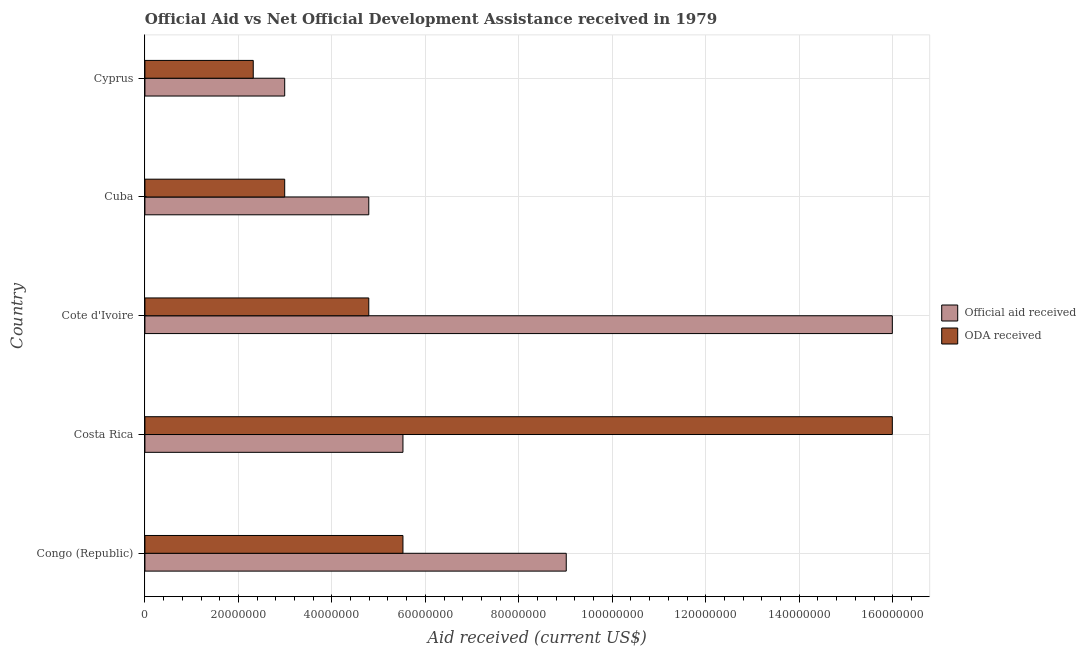How many bars are there on the 3rd tick from the top?
Make the answer very short. 2. How many bars are there on the 3rd tick from the bottom?
Your answer should be compact. 2. What is the label of the 5th group of bars from the top?
Offer a terse response. Congo (Republic). In how many cases, is the number of bars for a given country not equal to the number of legend labels?
Provide a succinct answer. 0. What is the oda received in Costa Rica?
Ensure brevity in your answer.  1.60e+08. Across all countries, what is the maximum oda received?
Your response must be concise. 1.60e+08. Across all countries, what is the minimum oda received?
Your response must be concise. 2.32e+07. In which country was the official aid received maximum?
Your response must be concise. Cote d'Ivoire. In which country was the official aid received minimum?
Your answer should be compact. Cyprus. What is the total official aid received in the graph?
Provide a succinct answer. 3.83e+08. What is the difference between the official aid received in Cuba and that in Cyprus?
Provide a short and direct response. 1.80e+07. What is the difference between the oda received in Cyprus and the official aid received in Congo (Republic)?
Give a very brief answer. -6.70e+07. What is the average oda received per country?
Keep it short and to the point. 6.32e+07. What is the difference between the official aid received and oda received in Congo (Republic)?
Your response must be concise. 3.49e+07. What is the ratio of the oda received in Congo (Republic) to that in Costa Rica?
Provide a succinct answer. 0.34. What is the difference between the highest and the second highest oda received?
Ensure brevity in your answer.  1.05e+08. What is the difference between the highest and the lowest oda received?
Offer a very short reply. 1.37e+08. Is the sum of the oda received in Congo (Republic) and Cyprus greater than the maximum official aid received across all countries?
Give a very brief answer. No. What does the 2nd bar from the top in Costa Rica represents?
Make the answer very short. Official aid received. What does the 1st bar from the bottom in Congo (Republic) represents?
Your answer should be very brief. Official aid received. How many bars are there?
Your answer should be very brief. 10. Are all the bars in the graph horizontal?
Give a very brief answer. Yes. How many countries are there in the graph?
Your answer should be compact. 5. Does the graph contain any zero values?
Your response must be concise. No. Where does the legend appear in the graph?
Offer a very short reply. Center right. How are the legend labels stacked?
Ensure brevity in your answer.  Vertical. What is the title of the graph?
Provide a succinct answer. Official Aid vs Net Official Development Assistance received in 1979 . Does "Total Population" appear as one of the legend labels in the graph?
Ensure brevity in your answer.  No. What is the label or title of the X-axis?
Your answer should be very brief. Aid received (current US$). What is the label or title of the Y-axis?
Provide a short and direct response. Country. What is the Aid received (current US$) of Official aid received in Congo (Republic)?
Give a very brief answer. 9.02e+07. What is the Aid received (current US$) in ODA received in Congo (Republic)?
Offer a very short reply. 5.52e+07. What is the Aid received (current US$) of Official aid received in Costa Rica?
Provide a succinct answer. 5.52e+07. What is the Aid received (current US$) of ODA received in Costa Rica?
Offer a very short reply. 1.60e+08. What is the Aid received (current US$) of Official aid received in Cote d'Ivoire?
Provide a short and direct response. 1.60e+08. What is the Aid received (current US$) of ODA received in Cote d'Ivoire?
Your answer should be compact. 4.79e+07. What is the Aid received (current US$) of Official aid received in Cuba?
Make the answer very short. 4.79e+07. What is the Aid received (current US$) of ODA received in Cuba?
Provide a short and direct response. 2.99e+07. What is the Aid received (current US$) in Official aid received in Cyprus?
Provide a succinct answer. 2.99e+07. What is the Aid received (current US$) in ODA received in Cyprus?
Keep it short and to the point. 2.32e+07. Across all countries, what is the maximum Aid received (current US$) of Official aid received?
Your answer should be very brief. 1.60e+08. Across all countries, what is the maximum Aid received (current US$) in ODA received?
Your answer should be compact. 1.60e+08. Across all countries, what is the minimum Aid received (current US$) in Official aid received?
Your response must be concise. 2.99e+07. Across all countries, what is the minimum Aid received (current US$) of ODA received?
Your response must be concise. 2.32e+07. What is the total Aid received (current US$) in Official aid received in the graph?
Your response must be concise. 3.83e+08. What is the total Aid received (current US$) of ODA received in the graph?
Offer a terse response. 3.16e+08. What is the difference between the Aid received (current US$) of Official aid received in Congo (Republic) and that in Costa Rica?
Provide a short and direct response. 3.49e+07. What is the difference between the Aid received (current US$) of ODA received in Congo (Republic) and that in Costa Rica?
Offer a terse response. -1.05e+08. What is the difference between the Aid received (current US$) of Official aid received in Congo (Republic) and that in Cote d'Ivoire?
Offer a terse response. -6.98e+07. What is the difference between the Aid received (current US$) of ODA received in Congo (Republic) and that in Cote d'Ivoire?
Your answer should be very brief. 7.31e+06. What is the difference between the Aid received (current US$) in Official aid received in Congo (Republic) and that in Cuba?
Offer a terse response. 4.22e+07. What is the difference between the Aid received (current US$) in ODA received in Congo (Republic) and that in Cuba?
Your answer should be very brief. 2.53e+07. What is the difference between the Aid received (current US$) of Official aid received in Congo (Republic) and that in Cyprus?
Your response must be concise. 6.02e+07. What is the difference between the Aid received (current US$) of ODA received in Congo (Republic) and that in Cyprus?
Your answer should be compact. 3.20e+07. What is the difference between the Aid received (current US$) in Official aid received in Costa Rica and that in Cote d'Ivoire?
Make the answer very short. -1.05e+08. What is the difference between the Aid received (current US$) in ODA received in Costa Rica and that in Cote d'Ivoire?
Your response must be concise. 1.12e+08. What is the difference between the Aid received (current US$) in Official aid received in Costa Rica and that in Cuba?
Provide a short and direct response. 7.31e+06. What is the difference between the Aid received (current US$) of ODA received in Costa Rica and that in Cuba?
Keep it short and to the point. 1.30e+08. What is the difference between the Aid received (current US$) of Official aid received in Costa Rica and that in Cyprus?
Ensure brevity in your answer.  2.53e+07. What is the difference between the Aid received (current US$) in ODA received in Costa Rica and that in Cyprus?
Provide a succinct answer. 1.37e+08. What is the difference between the Aid received (current US$) of Official aid received in Cote d'Ivoire and that in Cuba?
Offer a terse response. 1.12e+08. What is the difference between the Aid received (current US$) of ODA received in Cote d'Ivoire and that in Cuba?
Provide a succinct answer. 1.80e+07. What is the difference between the Aid received (current US$) in Official aid received in Cote d'Ivoire and that in Cyprus?
Provide a succinct answer. 1.30e+08. What is the difference between the Aid received (current US$) of ODA received in Cote d'Ivoire and that in Cyprus?
Your answer should be compact. 2.47e+07. What is the difference between the Aid received (current US$) of Official aid received in Cuba and that in Cyprus?
Provide a succinct answer. 1.80e+07. What is the difference between the Aid received (current US$) in ODA received in Cuba and that in Cyprus?
Provide a succinct answer. 6.73e+06. What is the difference between the Aid received (current US$) of Official aid received in Congo (Republic) and the Aid received (current US$) of ODA received in Costa Rica?
Ensure brevity in your answer.  -6.98e+07. What is the difference between the Aid received (current US$) of Official aid received in Congo (Republic) and the Aid received (current US$) of ODA received in Cote d'Ivoire?
Make the answer very short. 4.22e+07. What is the difference between the Aid received (current US$) in Official aid received in Congo (Republic) and the Aid received (current US$) in ODA received in Cuba?
Keep it short and to the point. 6.02e+07. What is the difference between the Aid received (current US$) in Official aid received in Congo (Republic) and the Aid received (current US$) in ODA received in Cyprus?
Offer a terse response. 6.70e+07. What is the difference between the Aid received (current US$) in Official aid received in Costa Rica and the Aid received (current US$) in ODA received in Cote d'Ivoire?
Provide a succinct answer. 7.31e+06. What is the difference between the Aid received (current US$) of Official aid received in Costa Rica and the Aid received (current US$) of ODA received in Cuba?
Offer a very short reply. 2.53e+07. What is the difference between the Aid received (current US$) in Official aid received in Costa Rica and the Aid received (current US$) in ODA received in Cyprus?
Give a very brief answer. 3.20e+07. What is the difference between the Aid received (current US$) of Official aid received in Cote d'Ivoire and the Aid received (current US$) of ODA received in Cuba?
Your response must be concise. 1.30e+08. What is the difference between the Aid received (current US$) of Official aid received in Cote d'Ivoire and the Aid received (current US$) of ODA received in Cyprus?
Your answer should be very brief. 1.37e+08. What is the difference between the Aid received (current US$) of Official aid received in Cuba and the Aid received (current US$) of ODA received in Cyprus?
Keep it short and to the point. 2.47e+07. What is the average Aid received (current US$) in Official aid received per country?
Make the answer very short. 7.66e+07. What is the average Aid received (current US$) in ODA received per country?
Make the answer very short. 6.32e+07. What is the difference between the Aid received (current US$) in Official aid received and Aid received (current US$) in ODA received in Congo (Republic)?
Ensure brevity in your answer.  3.49e+07. What is the difference between the Aid received (current US$) of Official aid received and Aid received (current US$) of ODA received in Costa Rica?
Give a very brief answer. -1.05e+08. What is the difference between the Aid received (current US$) of Official aid received and Aid received (current US$) of ODA received in Cote d'Ivoire?
Provide a succinct answer. 1.12e+08. What is the difference between the Aid received (current US$) of Official aid received and Aid received (current US$) of ODA received in Cuba?
Offer a terse response. 1.80e+07. What is the difference between the Aid received (current US$) of Official aid received and Aid received (current US$) of ODA received in Cyprus?
Ensure brevity in your answer.  6.73e+06. What is the ratio of the Aid received (current US$) of Official aid received in Congo (Republic) to that in Costa Rica?
Your answer should be compact. 1.63. What is the ratio of the Aid received (current US$) of ODA received in Congo (Republic) to that in Costa Rica?
Your answer should be very brief. 0.35. What is the ratio of the Aid received (current US$) of Official aid received in Congo (Republic) to that in Cote d'Ivoire?
Offer a terse response. 0.56. What is the ratio of the Aid received (current US$) in ODA received in Congo (Republic) to that in Cote d'Ivoire?
Provide a succinct answer. 1.15. What is the ratio of the Aid received (current US$) of Official aid received in Congo (Republic) to that in Cuba?
Ensure brevity in your answer.  1.88. What is the ratio of the Aid received (current US$) in ODA received in Congo (Republic) to that in Cuba?
Ensure brevity in your answer.  1.85. What is the ratio of the Aid received (current US$) of Official aid received in Congo (Republic) to that in Cyprus?
Provide a succinct answer. 3.01. What is the ratio of the Aid received (current US$) in ODA received in Congo (Republic) to that in Cyprus?
Your response must be concise. 2.38. What is the ratio of the Aid received (current US$) of Official aid received in Costa Rica to that in Cote d'Ivoire?
Make the answer very short. 0.35. What is the ratio of the Aid received (current US$) in ODA received in Costa Rica to that in Cote d'Ivoire?
Give a very brief answer. 3.34. What is the ratio of the Aid received (current US$) of Official aid received in Costa Rica to that in Cuba?
Give a very brief answer. 1.15. What is the ratio of the Aid received (current US$) of ODA received in Costa Rica to that in Cuba?
Give a very brief answer. 5.35. What is the ratio of the Aid received (current US$) of Official aid received in Costa Rica to that in Cyprus?
Provide a short and direct response. 1.85. What is the ratio of the Aid received (current US$) in ODA received in Costa Rica to that in Cyprus?
Your response must be concise. 6.9. What is the ratio of the Aid received (current US$) in Official aid received in Cote d'Ivoire to that in Cuba?
Your answer should be compact. 3.34. What is the ratio of the Aid received (current US$) of ODA received in Cote d'Ivoire to that in Cuba?
Your answer should be compact. 1.6. What is the ratio of the Aid received (current US$) of Official aid received in Cote d'Ivoire to that in Cyprus?
Offer a terse response. 5.35. What is the ratio of the Aid received (current US$) of ODA received in Cote d'Ivoire to that in Cyprus?
Provide a short and direct response. 2.07. What is the ratio of the Aid received (current US$) in Official aid received in Cuba to that in Cyprus?
Your response must be concise. 1.6. What is the ratio of the Aid received (current US$) in ODA received in Cuba to that in Cyprus?
Your response must be concise. 1.29. What is the difference between the highest and the second highest Aid received (current US$) in Official aid received?
Make the answer very short. 6.98e+07. What is the difference between the highest and the second highest Aid received (current US$) in ODA received?
Provide a succinct answer. 1.05e+08. What is the difference between the highest and the lowest Aid received (current US$) in Official aid received?
Keep it short and to the point. 1.30e+08. What is the difference between the highest and the lowest Aid received (current US$) of ODA received?
Offer a very short reply. 1.37e+08. 